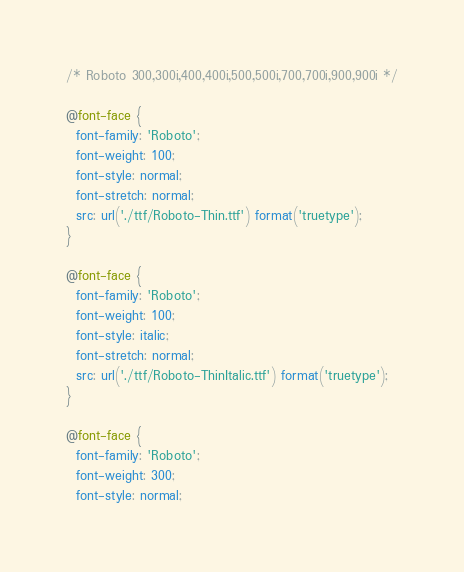<code> <loc_0><loc_0><loc_500><loc_500><_CSS_>/* Roboto 300,300i,400,400i,500,500i,700,700i,900,900i */

@font-face {
  font-family: 'Roboto';
  font-weight: 100;
  font-style: normal;
  font-stretch: normal;
  src: url('./ttf/Roboto-Thin.ttf') format('truetype');
}

@font-face {
  font-family: 'Roboto';
  font-weight: 100;
  font-style: italic;
  font-stretch: normal;
  src: url('./ttf/Roboto-ThinItalic.ttf') format('truetype');
}

@font-face {
  font-family: 'Roboto';
  font-weight: 300;
  font-style: normal;</code> 